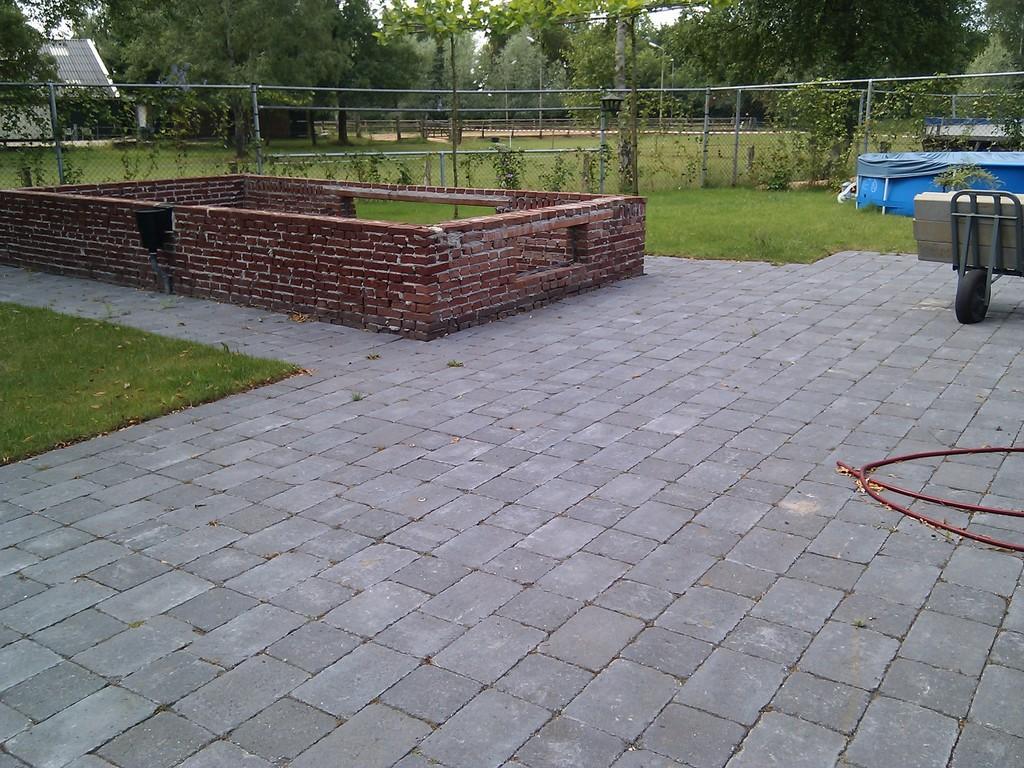Please provide a concise description of this image. In this picture there is a box on the trolley and there is an object. In the foreground there is a wall and there is a fence. At the back there is a house and there are trees, plants. At the top there is sky. At the bottom there is a pavement and there is grass and there is a pipe on the pavement. 